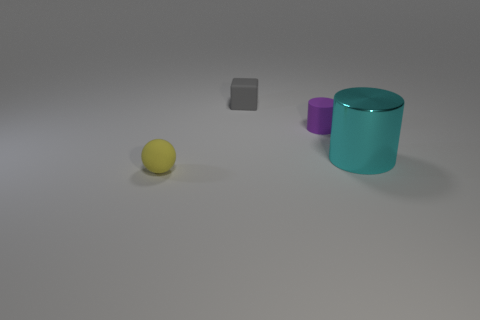How many tiny things are in front of the big object and behind the tiny cylinder?
Provide a succinct answer. 0. What is the size of the gray cube that is the same material as the purple cylinder?
Provide a succinct answer. Small. The yellow object is what size?
Make the answer very short. Small. What is the material of the gray block?
Provide a succinct answer. Rubber. Do the rubber object on the left side of the gray rubber object and the tiny gray matte block have the same size?
Your response must be concise. Yes. What number of things are small gray rubber cubes or small balls?
Offer a very short reply. 2. There is a rubber thing that is both on the left side of the tiny cylinder and in front of the cube; what is its size?
Make the answer very short. Small. What number of big cyan metal cylinders are there?
Ensure brevity in your answer.  1. How many cubes are either shiny objects or small purple matte objects?
Make the answer very short. 0. How many large metal objects are in front of the thing that is on the right side of the cylinder that is behind the metal cylinder?
Make the answer very short. 0. 